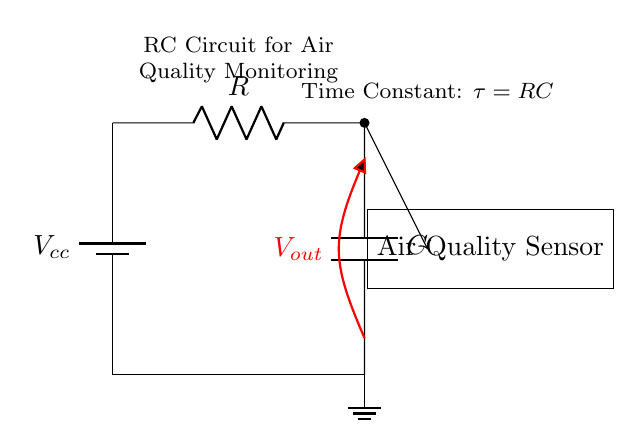What is the value of the resistor? The resistor value is represented by the letter R in the circuit diagram, which highlights its role and position.
Answer: R What does the capacitor store? The capacitor stores electrical charge, which is critical for smoothing fluctuations in the voltage supplied to sensors in this circuit.
Answer: Electrical charge What does V out represent? V out represents the output voltage of the circuit, which is measured across the capacitor and is essential for analyzing the air quality sensor's performance.
Answer: V out What is the time constant of this circuit? The time constant, denoted as τ, is calculated as the product of the resistance and capacitance, τ = RC, which indicates how quickly the circuit responds to changes.
Answer: τ = RC How many nodes are present in this RC circuit? The circuit contains three nodes: the power supply, the junction between the resistor and capacitor, and the ground connection, highlighting the connections between components.
Answer: 3 What is the function of the air quality sensor? The air quality sensor's function is to detect and measure air contaminants by processing the signals received, which are influenced by the RC circuit's output.
Answer: Measure air quality What type of circuit is shown? This is a Resistor-Capacitor, or RC, circuit, which is specifically designed for filtering, timing, and smoothing applications in electronic sensor systems.
Answer: RC Circuit 